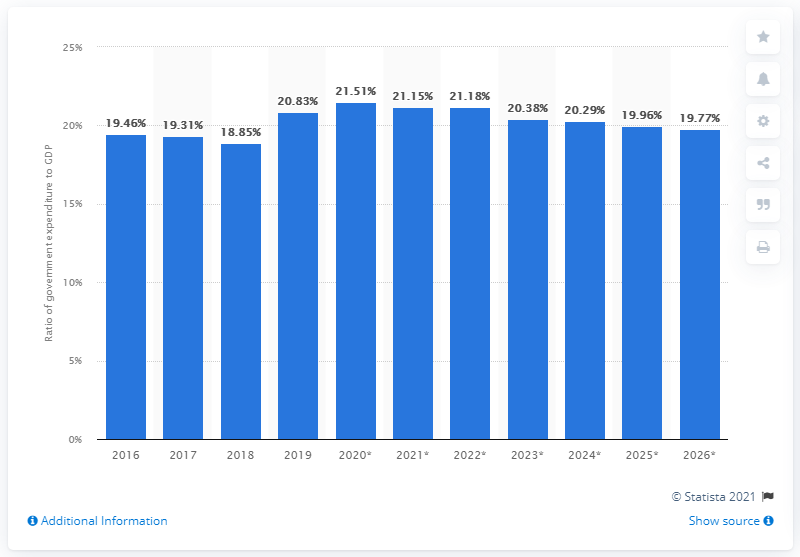How might this information about Sri Lanka's government expenditure influence investors or policy decisions? Investors may use this information to gauge the fiscal stability and economic health of Sri Lanka. A higher government expenditure percentage could indicate more state involvement in the economy, possibly suggesting greater stability but also higher taxation or public debt. Conversely, a reduction might imply efforts towards fiscal consolidation and could signal a more business-friendly environment but with reduced public services. Policymakers may use these trends to inform budgetary allocations, prioritize sectors for development, and maintain a balance between stimulating economic growth and managing the nation’s debt levels. 